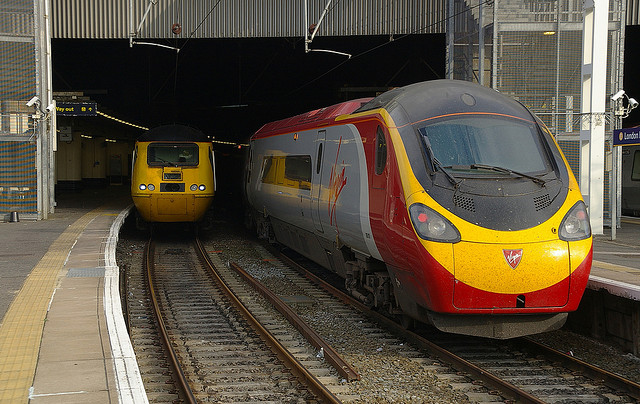Describe the setting and the time of day it seems to be in the photo. The photo depicts an overcast day with diffused natural light, suggesting it might be either morning or late afternoon. The station has a contemporary design with well-maintained tracks and platforms. Is there anything distinctive about the architecture or design of this station? The photo shows a station with modern amenities, including a high ceiling, protective coverings for the platforms, and a combination of historical and contemporary design elements that provide both functionality and aesthetic appeal. 